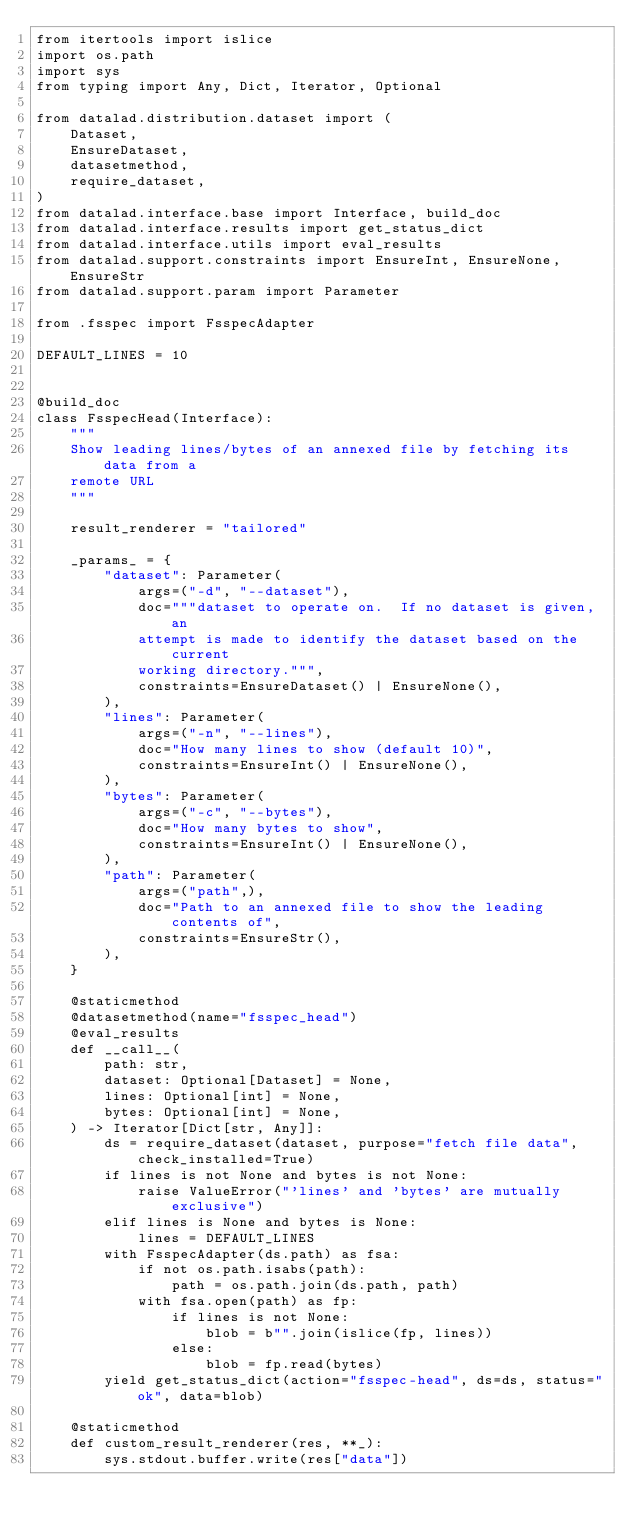<code> <loc_0><loc_0><loc_500><loc_500><_Python_>from itertools import islice
import os.path
import sys
from typing import Any, Dict, Iterator, Optional

from datalad.distribution.dataset import (
    Dataset,
    EnsureDataset,
    datasetmethod,
    require_dataset,
)
from datalad.interface.base import Interface, build_doc
from datalad.interface.results import get_status_dict
from datalad.interface.utils import eval_results
from datalad.support.constraints import EnsureInt, EnsureNone, EnsureStr
from datalad.support.param import Parameter

from .fsspec import FsspecAdapter

DEFAULT_LINES = 10


@build_doc
class FsspecHead(Interface):
    """
    Show leading lines/bytes of an annexed file by fetching its data from a
    remote URL
    """

    result_renderer = "tailored"

    _params_ = {
        "dataset": Parameter(
            args=("-d", "--dataset"),
            doc="""dataset to operate on.  If no dataset is given, an
            attempt is made to identify the dataset based on the current
            working directory.""",
            constraints=EnsureDataset() | EnsureNone(),
        ),
        "lines": Parameter(
            args=("-n", "--lines"),
            doc="How many lines to show (default 10)",
            constraints=EnsureInt() | EnsureNone(),
        ),
        "bytes": Parameter(
            args=("-c", "--bytes"),
            doc="How many bytes to show",
            constraints=EnsureInt() | EnsureNone(),
        ),
        "path": Parameter(
            args=("path",),
            doc="Path to an annexed file to show the leading contents of",
            constraints=EnsureStr(),
        ),
    }

    @staticmethod
    @datasetmethod(name="fsspec_head")
    @eval_results
    def __call__(
        path: str,
        dataset: Optional[Dataset] = None,
        lines: Optional[int] = None,
        bytes: Optional[int] = None,
    ) -> Iterator[Dict[str, Any]]:
        ds = require_dataset(dataset, purpose="fetch file data", check_installed=True)
        if lines is not None and bytes is not None:
            raise ValueError("'lines' and 'bytes' are mutually exclusive")
        elif lines is None and bytes is None:
            lines = DEFAULT_LINES
        with FsspecAdapter(ds.path) as fsa:
            if not os.path.isabs(path):
                path = os.path.join(ds.path, path)
            with fsa.open(path) as fp:
                if lines is not None:
                    blob = b"".join(islice(fp, lines))
                else:
                    blob = fp.read(bytes)
        yield get_status_dict(action="fsspec-head", ds=ds, status="ok", data=blob)

    @staticmethod
    def custom_result_renderer(res, **_):
        sys.stdout.buffer.write(res["data"])
</code> 